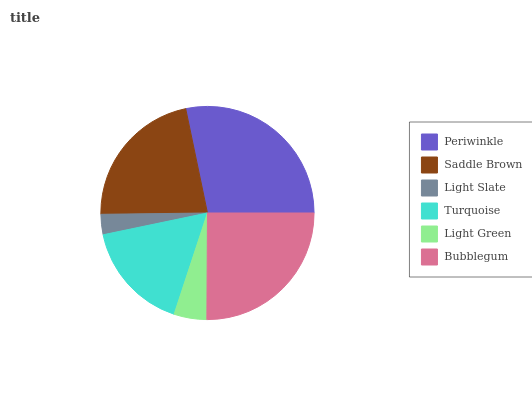Is Light Slate the minimum?
Answer yes or no. Yes. Is Periwinkle the maximum?
Answer yes or no. Yes. Is Saddle Brown the minimum?
Answer yes or no. No. Is Saddle Brown the maximum?
Answer yes or no. No. Is Periwinkle greater than Saddle Brown?
Answer yes or no. Yes. Is Saddle Brown less than Periwinkle?
Answer yes or no. Yes. Is Saddle Brown greater than Periwinkle?
Answer yes or no. No. Is Periwinkle less than Saddle Brown?
Answer yes or no. No. Is Saddle Brown the high median?
Answer yes or no. Yes. Is Turquoise the low median?
Answer yes or no. Yes. Is Turquoise the high median?
Answer yes or no. No. Is Periwinkle the low median?
Answer yes or no. No. 